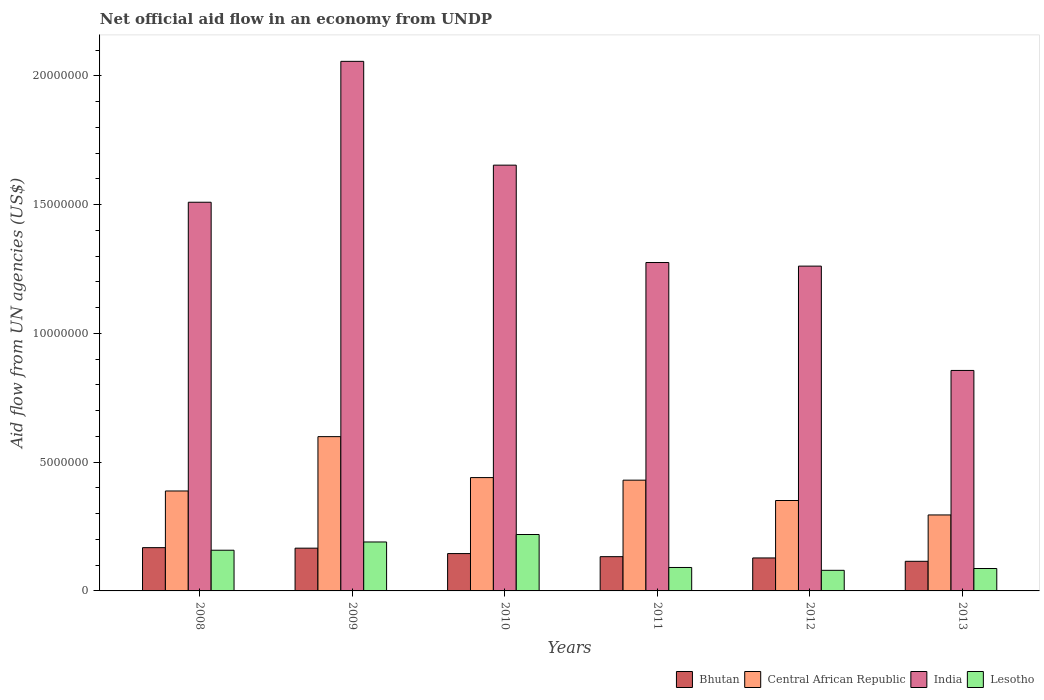How many groups of bars are there?
Your answer should be very brief. 6. Are the number of bars per tick equal to the number of legend labels?
Keep it short and to the point. Yes. How many bars are there on the 5th tick from the right?
Your answer should be very brief. 4. What is the label of the 4th group of bars from the left?
Make the answer very short. 2011. In how many cases, is the number of bars for a given year not equal to the number of legend labels?
Make the answer very short. 0. What is the net official aid flow in India in 2011?
Your answer should be very brief. 1.28e+07. Across all years, what is the maximum net official aid flow in Bhutan?
Offer a very short reply. 1.68e+06. Across all years, what is the minimum net official aid flow in Lesotho?
Keep it short and to the point. 8.00e+05. In which year was the net official aid flow in Central African Republic maximum?
Offer a terse response. 2009. In which year was the net official aid flow in Bhutan minimum?
Offer a terse response. 2013. What is the total net official aid flow in India in the graph?
Your response must be concise. 8.61e+07. What is the difference between the net official aid flow in Central African Republic in 2011 and that in 2013?
Provide a succinct answer. 1.35e+06. What is the difference between the net official aid flow in Lesotho in 2011 and the net official aid flow in Central African Republic in 2012?
Offer a terse response. -2.60e+06. What is the average net official aid flow in Central African Republic per year?
Offer a very short reply. 4.17e+06. In the year 2010, what is the difference between the net official aid flow in Lesotho and net official aid flow in Central African Republic?
Your answer should be compact. -2.21e+06. In how many years, is the net official aid flow in Central African Republic greater than 11000000 US$?
Make the answer very short. 0. What is the ratio of the net official aid flow in Lesotho in 2008 to that in 2009?
Make the answer very short. 0.83. Is the net official aid flow in Central African Republic in 2008 less than that in 2009?
Your answer should be very brief. Yes. Is the difference between the net official aid flow in Lesotho in 2008 and 2010 greater than the difference between the net official aid flow in Central African Republic in 2008 and 2010?
Provide a succinct answer. No. What is the difference between the highest and the lowest net official aid flow in Lesotho?
Your answer should be compact. 1.39e+06. In how many years, is the net official aid flow in Lesotho greater than the average net official aid flow in Lesotho taken over all years?
Your answer should be compact. 3. Is it the case that in every year, the sum of the net official aid flow in India and net official aid flow in Bhutan is greater than the sum of net official aid flow in Central African Republic and net official aid flow in Lesotho?
Ensure brevity in your answer.  Yes. What does the 3rd bar from the left in 2008 represents?
Provide a succinct answer. India. What does the 1st bar from the right in 2012 represents?
Give a very brief answer. Lesotho. Is it the case that in every year, the sum of the net official aid flow in India and net official aid flow in Lesotho is greater than the net official aid flow in Bhutan?
Provide a succinct answer. Yes. Are the values on the major ticks of Y-axis written in scientific E-notation?
Make the answer very short. No. Where does the legend appear in the graph?
Your answer should be very brief. Bottom right. How many legend labels are there?
Ensure brevity in your answer.  4. What is the title of the graph?
Keep it short and to the point. Net official aid flow in an economy from UNDP. Does "St. Martin (French part)" appear as one of the legend labels in the graph?
Provide a succinct answer. No. What is the label or title of the X-axis?
Your answer should be compact. Years. What is the label or title of the Y-axis?
Give a very brief answer. Aid flow from UN agencies (US$). What is the Aid flow from UN agencies (US$) in Bhutan in 2008?
Your answer should be compact. 1.68e+06. What is the Aid flow from UN agencies (US$) in Central African Republic in 2008?
Your answer should be compact. 3.88e+06. What is the Aid flow from UN agencies (US$) of India in 2008?
Make the answer very short. 1.51e+07. What is the Aid flow from UN agencies (US$) of Lesotho in 2008?
Give a very brief answer. 1.58e+06. What is the Aid flow from UN agencies (US$) of Bhutan in 2009?
Give a very brief answer. 1.66e+06. What is the Aid flow from UN agencies (US$) of Central African Republic in 2009?
Your response must be concise. 5.99e+06. What is the Aid flow from UN agencies (US$) of India in 2009?
Your response must be concise. 2.06e+07. What is the Aid flow from UN agencies (US$) in Lesotho in 2009?
Keep it short and to the point. 1.90e+06. What is the Aid flow from UN agencies (US$) of Bhutan in 2010?
Keep it short and to the point. 1.45e+06. What is the Aid flow from UN agencies (US$) of Central African Republic in 2010?
Offer a terse response. 4.40e+06. What is the Aid flow from UN agencies (US$) in India in 2010?
Offer a terse response. 1.65e+07. What is the Aid flow from UN agencies (US$) of Lesotho in 2010?
Provide a succinct answer. 2.19e+06. What is the Aid flow from UN agencies (US$) in Bhutan in 2011?
Your answer should be compact. 1.33e+06. What is the Aid flow from UN agencies (US$) in Central African Republic in 2011?
Your answer should be compact. 4.30e+06. What is the Aid flow from UN agencies (US$) of India in 2011?
Keep it short and to the point. 1.28e+07. What is the Aid flow from UN agencies (US$) of Lesotho in 2011?
Give a very brief answer. 9.10e+05. What is the Aid flow from UN agencies (US$) of Bhutan in 2012?
Give a very brief answer. 1.28e+06. What is the Aid flow from UN agencies (US$) in Central African Republic in 2012?
Give a very brief answer. 3.51e+06. What is the Aid flow from UN agencies (US$) of India in 2012?
Ensure brevity in your answer.  1.26e+07. What is the Aid flow from UN agencies (US$) in Lesotho in 2012?
Offer a very short reply. 8.00e+05. What is the Aid flow from UN agencies (US$) in Bhutan in 2013?
Offer a very short reply. 1.15e+06. What is the Aid flow from UN agencies (US$) in Central African Republic in 2013?
Provide a succinct answer. 2.95e+06. What is the Aid flow from UN agencies (US$) in India in 2013?
Offer a very short reply. 8.56e+06. What is the Aid flow from UN agencies (US$) in Lesotho in 2013?
Make the answer very short. 8.70e+05. Across all years, what is the maximum Aid flow from UN agencies (US$) in Bhutan?
Your answer should be compact. 1.68e+06. Across all years, what is the maximum Aid flow from UN agencies (US$) of Central African Republic?
Ensure brevity in your answer.  5.99e+06. Across all years, what is the maximum Aid flow from UN agencies (US$) in India?
Ensure brevity in your answer.  2.06e+07. Across all years, what is the maximum Aid flow from UN agencies (US$) in Lesotho?
Your answer should be compact. 2.19e+06. Across all years, what is the minimum Aid flow from UN agencies (US$) of Bhutan?
Provide a succinct answer. 1.15e+06. Across all years, what is the minimum Aid flow from UN agencies (US$) in Central African Republic?
Offer a terse response. 2.95e+06. Across all years, what is the minimum Aid flow from UN agencies (US$) in India?
Your answer should be very brief. 8.56e+06. What is the total Aid flow from UN agencies (US$) of Bhutan in the graph?
Your answer should be very brief. 8.55e+06. What is the total Aid flow from UN agencies (US$) of Central African Republic in the graph?
Make the answer very short. 2.50e+07. What is the total Aid flow from UN agencies (US$) in India in the graph?
Your answer should be compact. 8.61e+07. What is the total Aid flow from UN agencies (US$) of Lesotho in the graph?
Give a very brief answer. 8.25e+06. What is the difference between the Aid flow from UN agencies (US$) in Central African Republic in 2008 and that in 2009?
Give a very brief answer. -2.11e+06. What is the difference between the Aid flow from UN agencies (US$) in India in 2008 and that in 2009?
Your answer should be compact. -5.47e+06. What is the difference between the Aid flow from UN agencies (US$) of Lesotho in 2008 and that in 2009?
Provide a short and direct response. -3.20e+05. What is the difference between the Aid flow from UN agencies (US$) in Bhutan in 2008 and that in 2010?
Offer a terse response. 2.30e+05. What is the difference between the Aid flow from UN agencies (US$) in Central African Republic in 2008 and that in 2010?
Your answer should be very brief. -5.20e+05. What is the difference between the Aid flow from UN agencies (US$) of India in 2008 and that in 2010?
Offer a terse response. -1.44e+06. What is the difference between the Aid flow from UN agencies (US$) in Lesotho in 2008 and that in 2010?
Provide a succinct answer. -6.10e+05. What is the difference between the Aid flow from UN agencies (US$) of Central African Republic in 2008 and that in 2011?
Make the answer very short. -4.20e+05. What is the difference between the Aid flow from UN agencies (US$) in India in 2008 and that in 2011?
Provide a short and direct response. 2.34e+06. What is the difference between the Aid flow from UN agencies (US$) of Lesotho in 2008 and that in 2011?
Give a very brief answer. 6.70e+05. What is the difference between the Aid flow from UN agencies (US$) of Bhutan in 2008 and that in 2012?
Your answer should be compact. 4.00e+05. What is the difference between the Aid flow from UN agencies (US$) in India in 2008 and that in 2012?
Provide a short and direct response. 2.48e+06. What is the difference between the Aid flow from UN agencies (US$) of Lesotho in 2008 and that in 2012?
Keep it short and to the point. 7.80e+05. What is the difference between the Aid flow from UN agencies (US$) of Bhutan in 2008 and that in 2013?
Your response must be concise. 5.30e+05. What is the difference between the Aid flow from UN agencies (US$) of Central African Republic in 2008 and that in 2013?
Your response must be concise. 9.30e+05. What is the difference between the Aid flow from UN agencies (US$) of India in 2008 and that in 2013?
Your response must be concise. 6.53e+06. What is the difference between the Aid flow from UN agencies (US$) of Lesotho in 2008 and that in 2013?
Offer a terse response. 7.10e+05. What is the difference between the Aid flow from UN agencies (US$) of Central African Republic in 2009 and that in 2010?
Offer a very short reply. 1.59e+06. What is the difference between the Aid flow from UN agencies (US$) in India in 2009 and that in 2010?
Provide a short and direct response. 4.03e+06. What is the difference between the Aid flow from UN agencies (US$) in Central African Republic in 2009 and that in 2011?
Provide a short and direct response. 1.69e+06. What is the difference between the Aid flow from UN agencies (US$) in India in 2009 and that in 2011?
Offer a very short reply. 7.81e+06. What is the difference between the Aid flow from UN agencies (US$) in Lesotho in 2009 and that in 2011?
Ensure brevity in your answer.  9.90e+05. What is the difference between the Aid flow from UN agencies (US$) in Bhutan in 2009 and that in 2012?
Your answer should be very brief. 3.80e+05. What is the difference between the Aid flow from UN agencies (US$) of Central African Republic in 2009 and that in 2012?
Your response must be concise. 2.48e+06. What is the difference between the Aid flow from UN agencies (US$) in India in 2009 and that in 2012?
Offer a very short reply. 7.95e+06. What is the difference between the Aid flow from UN agencies (US$) of Lesotho in 2009 and that in 2012?
Make the answer very short. 1.10e+06. What is the difference between the Aid flow from UN agencies (US$) in Bhutan in 2009 and that in 2013?
Your answer should be compact. 5.10e+05. What is the difference between the Aid flow from UN agencies (US$) in Central African Republic in 2009 and that in 2013?
Your answer should be compact. 3.04e+06. What is the difference between the Aid flow from UN agencies (US$) in Lesotho in 2009 and that in 2013?
Provide a succinct answer. 1.03e+06. What is the difference between the Aid flow from UN agencies (US$) in Bhutan in 2010 and that in 2011?
Your response must be concise. 1.20e+05. What is the difference between the Aid flow from UN agencies (US$) of India in 2010 and that in 2011?
Your answer should be compact. 3.78e+06. What is the difference between the Aid flow from UN agencies (US$) in Lesotho in 2010 and that in 2011?
Ensure brevity in your answer.  1.28e+06. What is the difference between the Aid flow from UN agencies (US$) of Central African Republic in 2010 and that in 2012?
Provide a short and direct response. 8.90e+05. What is the difference between the Aid flow from UN agencies (US$) of India in 2010 and that in 2012?
Give a very brief answer. 3.92e+06. What is the difference between the Aid flow from UN agencies (US$) of Lesotho in 2010 and that in 2012?
Your answer should be very brief. 1.39e+06. What is the difference between the Aid flow from UN agencies (US$) of Bhutan in 2010 and that in 2013?
Keep it short and to the point. 3.00e+05. What is the difference between the Aid flow from UN agencies (US$) in Central African Republic in 2010 and that in 2013?
Your answer should be compact. 1.45e+06. What is the difference between the Aid flow from UN agencies (US$) of India in 2010 and that in 2013?
Make the answer very short. 7.97e+06. What is the difference between the Aid flow from UN agencies (US$) in Lesotho in 2010 and that in 2013?
Give a very brief answer. 1.32e+06. What is the difference between the Aid flow from UN agencies (US$) of Bhutan in 2011 and that in 2012?
Offer a terse response. 5.00e+04. What is the difference between the Aid flow from UN agencies (US$) in Central African Republic in 2011 and that in 2012?
Provide a succinct answer. 7.90e+05. What is the difference between the Aid flow from UN agencies (US$) of Lesotho in 2011 and that in 2012?
Your answer should be very brief. 1.10e+05. What is the difference between the Aid flow from UN agencies (US$) of Bhutan in 2011 and that in 2013?
Your answer should be compact. 1.80e+05. What is the difference between the Aid flow from UN agencies (US$) in Central African Republic in 2011 and that in 2013?
Keep it short and to the point. 1.35e+06. What is the difference between the Aid flow from UN agencies (US$) in India in 2011 and that in 2013?
Offer a very short reply. 4.19e+06. What is the difference between the Aid flow from UN agencies (US$) of Central African Republic in 2012 and that in 2013?
Your answer should be very brief. 5.60e+05. What is the difference between the Aid flow from UN agencies (US$) of India in 2012 and that in 2013?
Provide a succinct answer. 4.05e+06. What is the difference between the Aid flow from UN agencies (US$) in Bhutan in 2008 and the Aid flow from UN agencies (US$) in Central African Republic in 2009?
Your response must be concise. -4.31e+06. What is the difference between the Aid flow from UN agencies (US$) in Bhutan in 2008 and the Aid flow from UN agencies (US$) in India in 2009?
Offer a terse response. -1.89e+07. What is the difference between the Aid flow from UN agencies (US$) of Central African Republic in 2008 and the Aid flow from UN agencies (US$) of India in 2009?
Give a very brief answer. -1.67e+07. What is the difference between the Aid flow from UN agencies (US$) of Central African Republic in 2008 and the Aid flow from UN agencies (US$) of Lesotho in 2009?
Give a very brief answer. 1.98e+06. What is the difference between the Aid flow from UN agencies (US$) in India in 2008 and the Aid flow from UN agencies (US$) in Lesotho in 2009?
Your response must be concise. 1.32e+07. What is the difference between the Aid flow from UN agencies (US$) of Bhutan in 2008 and the Aid flow from UN agencies (US$) of Central African Republic in 2010?
Ensure brevity in your answer.  -2.72e+06. What is the difference between the Aid flow from UN agencies (US$) of Bhutan in 2008 and the Aid flow from UN agencies (US$) of India in 2010?
Keep it short and to the point. -1.48e+07. What is the difference between the Aid flow from UN agencies (US$) in Bhutan in 2008 and the Aid flow from UN agencies (US$) in Lesotho in 2010?
Give a very brief answer. -5.10e+05. What is the difference between the Aid flow from UN agencies (US$) in Central African Republic in 2008 and the Aid flow from UN agencies (US$) in India in 2010?
Provide a short and direct response. -1.26e+07. What is the difference between the Aid flow from UN agencies (US$) in Central African Republic in 2008 and the Aid flow from UN agencies (US$) in Lesotho in 2010?
Your answer should be compact. 1.69e+06. What is the difference between the Aid flow from UN agencies (US$) in India in 2008 and the Aid flow from UN agencies (US$) in Lesotho in 2010?
Offer a terse response. 1.29e+07. What is the difference between the Aid flow from UN agencies (US$) of Bhutan in 2008 and the Aid flow from UN agencies (US$) of Central African Republic in 2011?
Your response must be concise. -2.62e+06. What is the difference between the Aid flow from UN agencies (US$) in Bhutan in 2008 and the Aid flow from UN agencies (US$) in India in 2011?
Your response must be concise. -1.11e+07. What is the difference between the Aid flow from UN agencies (US$) of Bhutan in 2008 and the Aid flow from UN agencies (US$) of Lesotho in 2011?
Keep it short and to the point. 7.70e+05. What is the difference between the Aid flow from UN agencies (US$) of Central African Republic in 2008 and the Aid flow from UN agencies (US$) of India in 2011?
Make the answer very short. -8.87e+06. What is the difference between the Aid flow from UN agencies (US$) of Central African Republic in 2008 and the Aid flow from UN agencies (US$) of Lesotho in 2011?
Keep it short and to the point. 2.97e+06. What is the difference between the Aid flow from UN agencies (US$) in India in 2008 and the Aid flow from UN agencies (US$) in Lesotho in 2011?
Offer a terse response. 1.42e+07. What is the difference between the Aid flow from UN agencies (US$) of Bhutan in 2008 and the Aid flow from UN agencies (US$) of Central African Republic in 2012?
Your answer should be compact. -1.83e+06. What is the difference between the Aid flow from UN agencies (US$) in Bhutan in 2008 and the Aid flow from UN agencies (US$) in India in 2012?
Offer a very short reply. -1.09e+07. What is the difference between the Aid flow from UN agencies (US$) of Bhutan in 2008 and the Aid flow from UN agencies (US$) of Lesotho in 2012?
Provide a short and direct response. 8.80e+05. What is the difference between the Aid flow from UN agencies (US$) in Central African Republic in 2008 and the Aid flow from UN agencies (US$) in India in 2012?
Offer a terse response. -8.73e+06. What is the difference between the Aid flow from UN agencies (US$) in Central African Republic in 2008 and the Aid flow from UN agencies (US$) in Lesotho in 2012?
Provide a short and direct response. 3.08e+06. What is the difference between the Aid flow from UN agencies (US$) in India in 2008 and the Aid flow from UN agencies (US$) in Lesotho in 2012?
Keep it short and to the point. 1.43e+07. What is the difference between the Aid flow from UN agencies (US$) of Bhutan in 2008 and the Aid flow from UN agencies (US$) of Central African Republic in 2013?
Ensure brevity in your answer.  -1.27e+06. What is the difference between the Aid flow from UN agencies (US$) of Bhutan in 2008 and the Aid flow from UN agencies (US$) of India in 2013?
Provide a short and direct response. -6.88e+06. What is the difference between the Aid flow from UN agencies (US$) in Bhutan in 2008 and the Aid flow from UN agencies (US$) in Lesotho in 2013?
Offer a very short reply. 8.10e+05. What is the difference between the Aid flow from UN agencies (US$) in Central African Republic in 2008 and the Aid flow from UN agencies (US$) in India in 2013?
Offer a very short reply. -4.68e+06. What is the difference between the Aid flow from UN agencies (US$) of Central African Republic in 2008 and the Aid flow from UN agencies (US$) of Lesotho in 2013?
Your answer should be compact. 3.01e+06. What is the difference between the Aid flow from UN agencies (US$) in India in 2008 and the Aid flow from UN agencies (US$) in Lesotho in 2013?
Give a very brief answer. 1.42e+07. What is the difference between the Aid flow from UN agencies (US$) in Bhutan in 2009 and the Aid flow from UN agencies (US$) in Central African Republic in 2010?
Your response must be concise. -2.74e+06. What is the difference between the Aid flow from UN agencies (US$) of Bhutan in 2009 and the Aid flow from UN agencies (US$) of India in 2010?
Keep it short and to the point. -1.49e+07. What is the difference between the Aid flow from UN agencies (US$) in Bhutan in 2009 and the Aid flow from UN agencies (US$) in Lesotho in 2010?
Your answer should be very brief. -5.30e+05. What is the difference between the Aid flow from UN agencies (US$) of Central African Republic in 2009 and the Aid flow from UN agencies (US$) of India in 2010?
Make the answer very short. -1.05e+07. What is the difference between the Aid flow from UN agencies (US$) of Central African Republic in 2009 and the Aid flow from UN agencies (US$) of Lesotho in 2010?
Your answer should be very brief. 3.80e+06. What is the difference between the Aid flow from UN agencies (US$) of India in 2009 and the Aid flow from UN agencies (US$) of Lesotho in 2010?
Provide a succinct answer. 1.84e+07. What is the difference between the Aid flow from UN agencies (US$) in Bhutan in 2009 and the Aid flow from UN agencies (US$) in Central African Republic in 2011?
Your answer should be very brief. -2.64e+06. What is the difference between the Aid flow from UN agencies (US$) in Bhutan in 2009 and the Aid flow from UN agencies (US$) in India in 2011?
Keep it short and to the point. -1.11e+07. What is the difference between the Aid flow from UN agencies (US$) of Bhutan in 2009 and the Aid flow from UN agencies (US$) of Lesotho in 2011?
Ensure brevity in your answer.  7.50e+05. What is the difference between the Aid flow from UN agencies (US$) of Central African Republic in 2009 and the Aid flow from UN agencies (US$) of India in 2011?
Your answer should be very brief. -6.76e+06. What is the difference between the Aid flow from UN agencies (US$) in Central African Republic in 2009 and the Aid flow from UN agencies (US$) in Lesotho in 2011?
Make the answer very short. 5.08e+06. What is the difference between the Aid flow from UN agencies (US$) of India in 2009 and the Aid flow from UN agencies (US$) of Lesotho in 2011?
Give a very brief answer. 1.96e+07. What is the difference between the Aid flow from UN agencies (US$) in Bhutan in 2009 and the Aid flow from UN agencies (US$) in Central African Republic in 2012?
Make the answer very short. -1.85e+06. What is the difference between the Aid flow from UN agencies (US$) in Bhutan in 2009 and the Aid flow from UN agencies (US$) in India in 2012?
Provide a succinct answer. -1.10e+07. What is the difference between the Aid flow from UN agencies (US$) in Bhutan in 2009 and the Aid flow from UN agencies (US$) in Lesotho in 2012?
Ensure brevity in your answer.  8.60e+05. What is the difference between the Aid flow from UN agencies (US$) in Central African Republic in 2009 and the Aid flow from UN agencies (US$) in India in 2012?
Make the answer very short. -6.62e+06. What is the difference between the Aid flow from UN agencies (US$) in Central African Republic in 2009 and the Aid flow from UN agencies (US$) in Lesotho in 2012?
Your answer should be compact. 5.19e+06. What is the difference between the Aid flow from UN agencies (US$) of India in 2009 and the Aid flow from UN agencies (US$) of Lesotho in 2012?
Your answer should be very brief. 1.98e+07. What is the difference between the Aid flow from UN agencies (US$) in Bhutan in 2009 and the Aid flow from UN agencies (US$) in Central African Republic in 2013?
Keep it short and to the point. -1.29e+06. What is the difference between the Aid flow from UN agencies (US$) of Bhutan in 2009 and the Aid flow from UN agencies (US$) of India in 2013?
Ensure brevity in your answer.  -6.90e+06. What is the difference between the Aid flow from UN agencies (US$) in Bhutan in 2009 and the Aid flow from UN agencies (US$) in Lesotho in 2013?
Ensure brevity in your answer.  7.90e+05. What is the difference between the Aid flow from UN agencies (US$) in Central African Republic in 2009 and the Aid flow from UN agencies (US$) in India in 2013?
Your answer should be very brief. -2.57e+06. What is the difference between the Aid flow from UN agencies (US$) of Central African Republic in 2009 and the Aid flow from UN agencies (US$) of Lesotho in 2013?
Make the answer very short. 5.12e+06. What is the difference between the Aid flow from UN agencies (US$) of India in 2009 and the Aid flow from UN agencies (US$) of Lesotho in 2013?
Your answer should be very brief. 1.97e+07. What is the difference between the Aid flow from UN agencies (US$) in Bhutan in 2010 and the Aid flow from UN agencies (US$) in Central African Republic in 2011?
Make the answer very short. -2.85e+06. What is the difference between the Aid flow from UN agencies (US$) in Bhutan in 2010 and the Aid flow from UN agencies (US$) in India in 2011?
Ensure brevity in your answer.  -1.13e+07. What is the difference between the Aid flow from UN agencies (US$) of Bhutan in 2010 and the Aid flow from UN agencies (US$) of Lesotho in 2011?
Ensure brevity in your answer.  5.40e+05. What is the difference between the Aid flow from UN agencies (US$) of Central African Republic in 2010 and the Aid flow from UN agencies (US$) of India in 2011?
Your answer should be very brief. -8.35e+06. What is the difference between the Aid flow from UN agencies (US$) of Central African Republic in 2010 and the Aid flow from UN agencies (US$) of Lesotho in 2011?
Offer a terse response. 3.49e+06. What is the difference between the Aid flow from UN agencies (US$) in India in 2010 and the Aid flow from UN agencies (US$) in Lesotho in 2011?
Give a very brief answer. 1.56e+07. What is the difference between the Aid flow from UN agencies (US$) of Bhutan in 2010 and the Aid flow from UN agencies (US$) of Central African Republic in 2012?
Your answer should be compact. -2.06e+06. What is the difference between the Aid flow from UN agencies (US$) of Bhutan in 2010 and the Aid flow from UN agencies (US$) of India in 2012?
Provide a succinct answer. -1.12e+07. What is the difference between the Aid flow from UN agencies (US$) of Bhutan in 2010 and the Aid flow from UN agencies (US$) of Lesotho in 2012?
Your response must be concise. 6.50e+05. What is the difference between the Aid flow from UN agencies (US$) in Central African Republic in 2010 and the Aid flow from UN agencies (US$) in India in 2012?
Provide a short and direct response. -8.21e+06. What is the difference between the Aid flow from UN agencies (US$) of Central African Republic in 2010 and the Aid flow from UN agencies (US$) of Lesotho in 2012?
Provide a succinct answer. 3.60e+06. What is the difference between the Aid flow from UN agencies (US$) in India in 2010 and the Aid flow from UN agencies (US$) in Lesotho in 2012?
Ensure brevity in your answer.  1.57e+07. What is the difference between the Aid flow from UN agencies (US$) of Bhutan in 2010 and the Aid flow from UN agencies (US$) of Central African Republic in 2013?
Keep it short and to the point. -1.50e+06. What is the difference between the Aid flow from UN agencies (US$) in Bhutan in 2010 and the Aid flow from UN agencies (US$) in India in 2013?
Provide a succinct answer. -7.11e+06. What is the difference between the Aid flow from UN agencies (US$) in Bhutan in 2010 and the Aid flow from UN agencies (US$) in Lesotho in 2013?
Provide a succinct answer. 5.80e+05. What is the difference between the Aid flow from UN agencies (US$) of Central African Republic in 2010 and the Aid flow from UN agencies (US$) of India in 2013?
Provide a succinct answer. -4.16e+06. What is the difference between the Aid flow from UN agencies (US$) of Central African Republic in 2010 and the Aid flow from UN agencies (US$) of Lesotho in 2013?
Make the answer very short. 3.53e+06. What is the difference between the Aid flow from UN agencies (US$) of India in 2010 and the Aid flow from UN agencies (US$) of Lesotho in 2013?
Provide a succinct answer. 1.57e+07. What is the difference between the Aid flow from UN agencies (US$) of Bhutan in 2011 and the Aid flow from UN agencies (US$) of Central African Republic in 2012?
Offer a very short reply. -2.18e+06. What is the difference between the Aid flow from UN agencies (US$) of Bhutan in 2011 and the Aid flow from UN agencies (US$) of India in 2012?
Provide a short and direct response. -1.13e+07. What is the difference between the Aid flow from UN agencies (US$) of Bhutan in 2011 and the Aid flow from UN agencies (US$) of Lesotho in 2012?
Keep it short and to the point. 5.30e+05. What is the difference between the Aid flow from UN agencies (US$) of Central African Republic in 2011 and the Aid flow from UN agencies (US$) of India in 2012?
Your answer should be very brief. -8.31e+06. What is the difference between the Aid flow from UN agencies (US$) in Central African Republic in 2011 and the Aid flow from UN agencies (US$) in Lesotho in 2012?
Offer a very short reply. 3.50e+06. What is the difference between the Aid flow from UN agencies (US$) of India in 2011 and the Aid flow from UN agencies (US$) of Lesotho in 2012?
Give a very brief answer. 1.20e+07. What is the difference between the Aid flow from UN agencies (US$) of Bhutan in 2011 and the Aid flow from UN agencies (US$) of Central African Republic in 2013?
Your answer should be very brief. -1.62e+06. What is the difference between the Aid flow from UN agencies (US$) in Bhutan in 2011 and the Aid flow from UN agencies (US$) in India in 2013?
Your answer should be very brief. -7.23e+06. What is the difference between the Aid flow from UN agencies (US$) of Bhutan in 2011 and the Aid flow from UN agencies (US$) of Lesotho in 2013?
Your answer should be compact. 4.60e+05. What is the difference between the Aid flow from UN agencies (US$) of Central African Republic in 2011 and the Aid flow from UN agencies (US$) of India in 2013?
Your answer should be compact. -4.26e+06. What is the difference between the Aid flow from UN agencies (US$) in Central African Republic in 2011 and the Aid flow from UN agencies (US$) in Lesotho in 2013?
Provide a succinct answer. 3.43e+06. What is the difference between the Aid flow from UN agencies (US$) in India in 2011 and the Aid flow from UN agencies (US$) in Lesotho in 2013?
Offer a terse response. 1.19e+07. What is the difference between the Aid flow from UN agencies (US$) in Bhutan in 2012 and the Aid flow from UN agencies (US$) in Central African Republic in 2013?
Give a very brief answer. -1.67e+06. What is the difference between the Aid flow from UN agencies (US$) in Bhutan in 2012 and the Aid flow from UN agencies (US$) in India in 2013?
Your answer should be very brief. -7.28e+06. What is the difference between the Aid flow from UN agencies (US$) of Central African Republic in 2012 and the Aid flow from UN agencies (US$) of India in 2013?
Your response must be concise. -5.05e+06. What is the difference between the Aid flow from UN agencies (US$) of Central African Republic in 2012 and the Aid flow from UN agencies (US$) of Lesotho in 2013?
Give a very brief answer. 2.64e+06. What is the difference between the Aid flow from UN agencies (US$) in India in 2012 and the Aid flow from UN agencies (US$) in Lesotho in 2013?
Your answer should be very brief. 1.17e+07. What is the average Aid flow from UN agencies (US$) in Bhutan per year?
Offer a terse response. 1.42e+06. What is the average Aid flow from UN agencies (US$) of Central African Republic per year?
Make the answer very short. 4.17e+06. What is the average Aid flow from UN agencies (US$) in India per year?
Give a very brief answer. 1.44e+07. What is the average Aid flow from UN agencies (US$) in Lesotho per year?
Your answer should be compact. 1.38e+06. In the year 2008, what is the difference between the Aid flow from UN agencies (US$) of Bhutan and Aid flow from UN agencies (US$) of Central African Republic?
Provide a short and direct response. -2.20e+06. In the year 2008, what is the difference between the Aid flow from UN agencies (US$) of Bhutan and Aid flow from UN agencies (US$) of India?
Offer a terse response. -1.34e+07. In the year 2008, what is the difference between the Aid flow from UN agencies (US$) in Central African Republic and Aid flow from UN agencies (US$) in India?
Offer a very short reply. -1.12e+07. In the year 2008, what is the difference between the Aid flow from UN agencies (US$) in Central African Republic and Aid flow from UN agencies (US$) in Lesotho?
Provide a succinct answer. 2.30e+06. In the year 2008, what is the difference between the Aid flow from UN agencies (US$) of India and Aid flow from UN agencies (US$) of Lesotho?
Make the answer very short. 1.35e+07. In the year 2009, what is the difference between the Aid flow from UN agencies (US$) of Bhutan and Aid flow from UN agencies (US$) of Central African Republic?
Your answer should be compact. -4.33e+06. In the year 2009, what is the difference between the Aid flow from UN agencies (US$) of Bhutan and Aid flow from UN agencies (US$) of India?
Ensure brevity in your answer.  -1.89e+07. In the year 2009, what is the difference between the Aid flow from UN agencies (US$) in Central African Republic and Aid flow from UN agencies (US$) in India?
Give a very brief answer. -1.46e+07. In the year 2009, what is the difference between the Aid flow from UN agencies (US$) of Central African Republic and Aid flow from UN agencies (US$) of Lesotho?
Offer a very short reply. 4.09e+06. In the year 2009, what is the difference between the Aid flow from UN agencies (US$) of India and Aid flow from UN agencies (US$) of Lesotho?
Ensure brevity in your answer.  1.87e+07. In the year 2010, what is the difference between the Aid flow from UN agencies (US$) in Bhutan and Aid flow from UN agencies (US$) in Central African Republic?
Offer a very short reply. -2.95e+06. In the year 2010, what is the difference between the Aid flow from UN agencies (US$) of Bhutan and Aid flow from UN agencies (US$) of India?
Your response must be concise. -1.51e+07. In the year 2010, what is the difference between the Aid flow from UN agencies (US$) in Bhutan and Aid flow from UN agencies (US$) in Lesotho?
Give a very brief answer. -7.40e+05. In the year 2010, what is the difference between the Aid flow from UN agencies (US$) in Central African Republic and Aid flow from UN agencies (US$) in India?
Your response must be concise. -1.21e+07. In the year 2010, what is the difference between the Aid flow from UN agencies (US$) of Central African Republic and Aid flow from UN agencies (US$) of Lesotho?
Provide a succinct answer. 2.21e+06. In the year 2010, what is the difference between the Aid flow from UN agencies (US$) in India and Aid flow from UN agencies (US$) in Lesotho?
Ensure brevity in your answer.  1.43e+07. In the year 2011, what is the difference between the Aid flow from UN agencies (US$) in Bhutan and Aid flow from UN agencies (US$) in Central African Republic?
Your answer should be very brief. -2.97e+06. In the year 2011, what is the difference between the Aid flow from UN agencies (US$) in Bhutan and Aid flow from UN agencies (US$) in India?
Your answer should be very brief. -1.14e+07. In the year 2011, what is the difference between the Aid flow from UN agencies (US$) of Bhutan and Aid flow from UN agencies (US$) of Lesotho?
Offer a terse response. 4.20e+05. In the year 2011, what is the difference between the Aid flow from UN agencies (US$) in Central African Republic and Aid flow from UN agencies (US$) in India?
Keep it short and to the point. -8.45e+06. In the year 2011, what is the difference between the Aid flow from UN agencies (US$) of Central African Republic and Aid flow from UN agencies (US$) of Lesotho?
Your answer should be compact. 3.39e+06. In the year 2011, what is the difference between the Aid flow from UN agencies (US$) in India and Aid flow from UN agencies (US$) in Lesotho?
Your answer should be compact. 1.18e+07. In the year 2012, what is the difference between the Aid flow from UN agencies (US$) of Bhutan and Aid flow from UN agencies (US$) of Central African Republic?
Ensure brevity in your answer.  -2.23e+06. In the year 2012, what is the difference between the Aid flow from UN agencies (US$) of Bhutan and Aid flow from UN agencies (US$) of India?
Offer a very short reply. -1.13e+07. In the year 2012, what is the difference between the Aid flow from UN agencies (US$) in Bhutan and Aid flow from UN agencies (US$) in Lesotho?
Ensure brevity in your answer.  4.80e+05. In the year 2012, what is the difference between the Aid flow from UN agencies (US$) of Central African Republic and Aid flow from UN agencies (US$) of India?
Give a very brief answer. -9.10e+06. In the year 2012, what is the difference between the Aid flow from UN agencies (US$) in Central African Republic and Aid flow from UN agencies (US$) in Lesotho?
Provide a short and direct response. 2.71e+06. In the year 2012, what is the difference between the Aid flow from UN agencies (US$) of India and Aid flow from UN agencies (US$) of Lesotho?
Your answer should be compact. 1.18e+07. In the year 2013, what is the difference between the Aid flow from UN agencies (US$) in Bhutan and Aid flow from UN agencies (US$) in Central African Republic?
Your response must be concise. -1.80e+06. In the year 2013, what is the difference between the Aid flow from UN agencies (US$) of Bhutan and Aid flow from UN agencies (US$) of India?
Provide a succinct answer. -7.41e+06. In the year 2013, what is the difference between the Aid flow from UN agencies (US$) in Bhutan and Aid flow from UN agencies (US$) in Lesotho?
Provide a succinct answer. 2.80e+05. In the year 2013, what is the difference between the Aid flow from UN agencies (US$) of Central African Republic and Aid flow from UN agencies (US$) of India?
Provide a succinct answer. -5.61e+06. In the year 2013, what is the difference between the Aid flow from UN agencies (US$) in Central African Republic and Aid flow from UN agencies (US$) in Lesotho?
Keep it short and to the point. 2.08e+06. In the year 2013, what is the difference between the Aid flow from UN agencies (US$) in India and Aid flow from UN agencies (US$) in Lesotho?
Give a very brief answer. 7.69e+06. What is the ratio of the Aid flow from UN agencies (US$) of Central African Republic in 2008 to that in 2009?
Keep it short and to the point. 0.65. What is the ratio of the Aid flow from UN agencies (US$) of India in 2008 to that in 2009?
Your response must be concise. 0.73. What is the ratio of the Aid flow from UN agencies (US$) of Lesotho in 2008 to that in 2009?
Make the answer very short. 0.83. What is the ratio of the Aid flow from UN agencies (US$) of Bhutan in 2008 to that in 2010?
Your answer should be very brief. 1.16. What is the ratio of the Aid flow from UN agencies (US$) in Central African Republic in 2008 to that in 2010?
Your answer should be very brief. 0.88. What is the ratio of the Aid flow from UN agencies (US$) of India in 2008 to that in 2010?
Provide a succinct answer. 0.91. What is the ratio of the Aid flow from UN agencies (US$) of Lesotho in 2008 to that in 2010?
Give a very brief answer. 0.72. What is the ratio of the Aid flow from UN agencies (US$) in Bhutan in 2008 to that in 2011?
Your response must be concise. 1.26. What is the ratio of the Aid flow from UN agencies (US$) in Central African Republic in 2008 to that in 2011?
Your answer should be very brief. 0.9. What is the ratio of the Aid flow from UN agencies (US$) of India in 2008 to that in 2011?
Provide a short and direct response. 1.18. What is the ratio of the Aid flow from UN agencies (US$) of Lesotho in 2008 to that in 2011?
Your answer should be compact. 1.74. What is the ratio of the Aid flow from UN agencies (US$) in Bhutan in 2008 to that in 2012?
Your answer should be compact. 1.31. What is the ratio of the Aid flow from UN agencies (US$) of Central African Republic in 2008 to that in 2012?
Your answer should be very brief. 1.11. What is the ratio of the Aid flow from UN agencies (US$) of India in 2008 to that in 2012?
Provide a succinct answer. 1.2. What is the ratio of the Aid flow from UN agencies (US$) of Lesotho in 2008 to that in 2012?
Give a very brief answer. 1.98. What is the ratio of the Aid flow from UN agencies (US$) of Bhutan in 2008 to that in 2013?
Make the answer very short. 1.46. What is the ratio of the Aid flow from UN agencies (US$) in Central African Republic in 2008 to that in 2013?
Offer a terse response. 1.32. What is the ratio of the Aid flow from UN agencies (US$) in India in 2008 to that in 2013?
Ensure brevity in your answer.  1.76. What is the ratio of the Aid flow from UN agencies (US$) of Lesotho in 2008 to that in 2013?
Make the answer very short. 1.82. What is the ratio of the Aid flow from UN agencies (US$) in Bhutan in 2009 to that in 2010?
Your answer should be compact. 1.14. What is the ratio of the Aid flow from UN agencies (US$) of Central African Republic in 2009 to that in 2010?
Ensure brevity in your answer.  1.36. What is the ratio of the Aid flow from UN agencies (US$) in India in 2009 to that in 2010?
Your response must be concise. 1.24. What is the ratio of the Aid flow from UN agencies (US$) in Lesotho in 2009 to that in 2010?
Make the answer very short. 0.87. What is the ratio of the Aid flow from UN agencies (US$) in Bhutan in 2009 to that in 2011?
Your answer should be compact. 1.25. What is the ratio of the Aid flow from UN agencies (US$) of Central African Republic in 2009 to that in 2011?
Provide a succinct answer. 1.39. What is the ratio of the Aid flow from UN agencies (US$) in India in 2009 to that in 2011?
Offer a very short reply. 1.61. What is the ratio of the Aid flow from UN agencies (US$) in Lesotho in 2009 to that in 2011?
Provide a succinct answer. 2.09. What is the ratio of the Aid flow from UN agencies (US$) of Bhutan in 2009 to that in 2012?
Your response must be concise. 1.3. What is the ratio of the Aid flow from UN agencies (US$) of Central African Republic in 2009 to that in 2012?
Give a very brief answer. 1.71. What is the ratio of the Aid flow from UN agencies (US$) in India in 2009 to that in 2012?
Keep it short and to the point. 1.63. What is the ratio of the Aid flow from UN agencies (US$) of Lesotho in 2009 to that in 2012?
Ensure brevity in your answer.  2.38. What is the ratio of the Aid flow from UN agencies (US$) of Bhutan in 2009 to that in 2013?
Make the answer very short. 1.44. What is the ratio of the Aid flow from UN agencies (US$) of Central African Republic in 2009 to that in 2013?
Your answer should be compact. 2.03. What is the ratio of the Aid flow from UN agencies (US$) in India in 2009 to that in 2013?
Your answer should be very brief. 2.4. What is the ratio of the Aid flow from UN agencies (US$) in Lesotho in 2009 to that in 2013?
Make the answer very short. 2.18. What is the ratio of the Aid flow from UN agencies (US$) in Bhutan in 2010 to that in 2011?
Your answer should be very brief. 1.09. What is the ratio of the Aid flow from UN agencies (US$) in Central African Republic in 2010 to that in 2011?
Provide a succinct answer. 1.02. What is the ratio of the Aid flow from UN agencies (US$) in India in 2010 to that in 2011?
Offer a very short reply. 1.3. What is the ratio of the Aid flow from UN agencies (US$) of Lesotho in 2010 to that in 2011?
Keep it short and to the point. 2.41. What is the ratio of the Aid flow from UN agencies (US$) in Bhutan in 2010 to that in 2012?
Offer a terse response. 1.13. What is the ratio of the Aid flow from UN agencies (US$) of Central African Republic in 2010 to that in 2012?
Offer a very short reply. 1.25. What is the ratio of the Aid flow from UN agencies (US$) of India in 2010 to that in 2012?
Your answer should be very brief. 1.31. What is the ratio of the Aid flow from UN agencies (US$) in Lesotho in 2010 to that in 2012?
Your answer should be compact. 2.74. What is the ratio of the Aid flow from UN agencies (US$) of Bhutan in 2010 to that in 2013?
Your response must be concise. 1.26. What is the ratio of the Aid flow from UN agencies (US$) of Central African Republic in 2010 to that in 2013?
Your response must be concise. 1.49. What is the ratio of the Aid flow from UN agencies (US$) of India in 2010 to that in 2013?
Keep it short and to the point. 1.93. What is the ratio of the Aid flow from UN agencies (US$) in Lesotho in 2010 to that in 2013?
Your answer should be compact. 2.52. What is the ratio of the Aid flow from UN agencies (US$) of Bhutan in 2011 to that in 2012?
Ensure brevity in your answer.  1.04. What is the ratio of the Aid flow from UN agencies (US$) of Central African Republic in 2011 to that in 2012?
Keep it short and to the point. 1.23. What is the ratio of the Aid flow from UN agencies (US$) in India in 2011 to that in 2012?
Offer a very short reply. 1.01. What is the ratio of the Aid flow from UN agencies (US$) of Lesotho in 2011 to that in 2012?
Offer a terse response. 1.14. What is the ratio of the Aid flow from UN agencies (US$) of Bhutan in 2011 to that in 2013?
Provide a short and direct response. 1.16. What is the ratio of the Aid flow from UN agencies (US$) of Central African Republic in 2011 to that in 2013?
Your answer should be very brief. 1.46. What is the ratio of the Aid flow from UN agencies (US$) of India in 2011 to that in 2013?
Provide a succinct answer. 1.49. What is the ratio of the Aid flow from UN agencies (US$) in Lesotho in 2011 to that in 2013?
Offer a very short reply. 1.05. What is the ratio of the Aid flow from UN agencies (US$) of Bhutan in 2012 to that in 2013?
Your answer should be compact. 1.11. What is the ratio of the Aid flow from UN agencies (US$) of Central African Republic in 2012 to that in 2013?
Provide a short and direct response. 1.19. What is the ratio of the Aid flow from UN agencies (US$) of India in 2012 to that in 2013?
Your answer should be very brief. 1.47. What is the ratio of the Aid flow from UN agencies (US$) of Lesotho in 2012 to that in 2013?
Ensure brevity in your answer.  0.92. What is the difference between the highest and the second highest Aid flow from UN agencies (US$) in Central African Republic?
Your answer should be compact. 1.59e+06. What is the difference between the highest and the second highest Aid flow from UN agencies (US$) in India?
Provide a short and direct response. 4.03e+06. What is the difference between the highest and the second highest Aid flow from UN agencies (US$) of Lesotho?
Offer a very short reply. 2.90e+05. What is the difference between the highest and the lowest Aid flow from UN agencies (US$) of Bhutan?
Provide a succinct answer. 5.30e+05. What is the difference between the highest and the lowest Aid flow from UN agencies (US$) in Central African Republic?
Provide a succinct answer. 3.04e+06. What is the difference between the highest and the lowest Aid flow from UN agencies (US$) of India?
Your answer should be very brief. 1.20e+07. What is the difference between the highest and the lowest Aid flow from UN agencies (US$) in Lesotho?
Ensure brevity in your answer.  1.39e+06. 